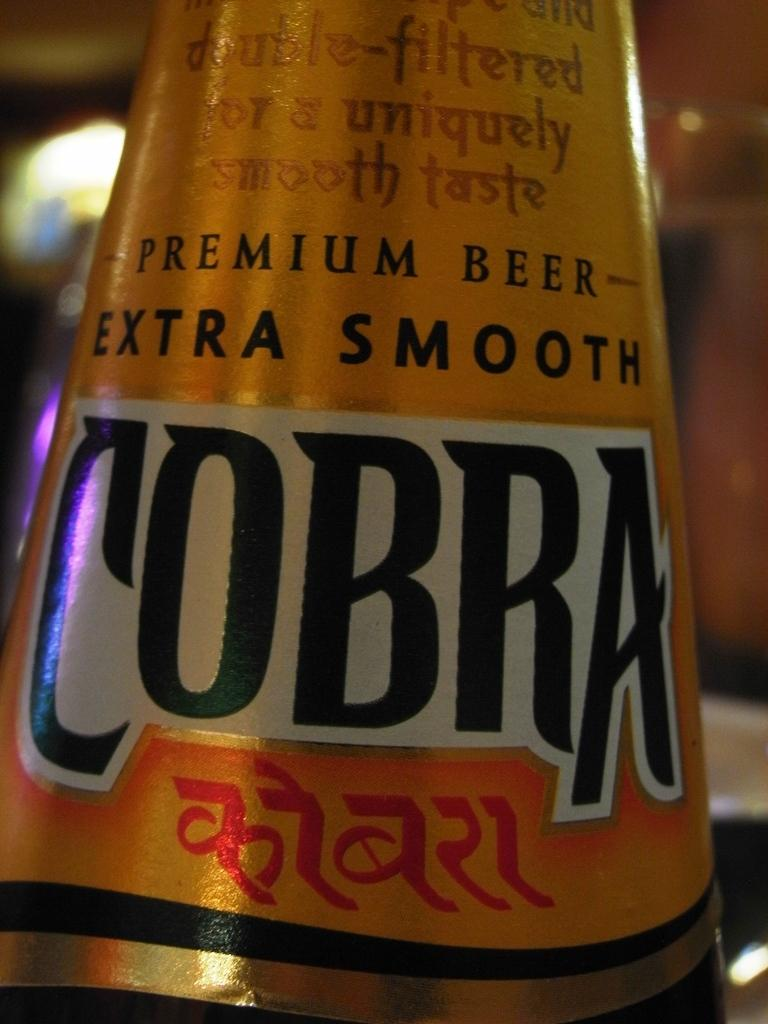<image>
Describe the image concisely. The Cobra beer label claims that it is extra smooth. 